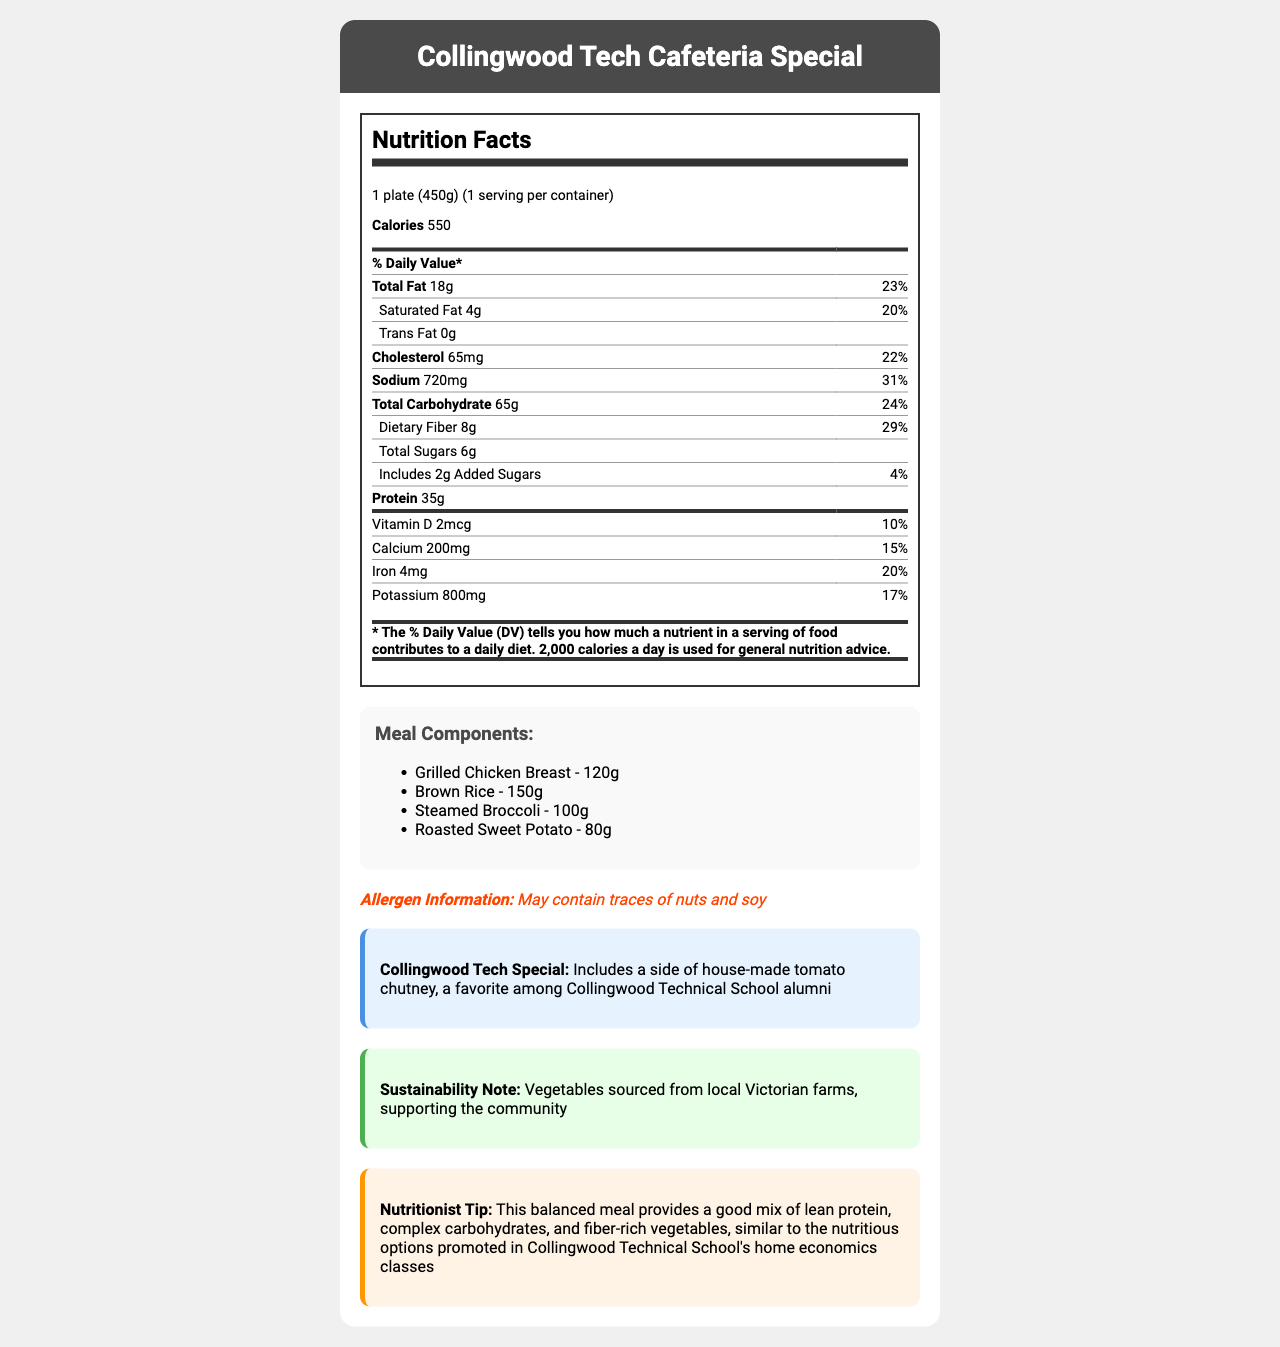what is the serving size of the balanced meal? The serving size is clearly stated in the "Nutrition Facts" section at the beginning of the document.
Answer: 1 plate (450g) how many calories are there per serving? The calorie content is listed right under the serving size in the Nutrition Facts section.
Answer: 550 calories what is the total fat content and its daily value percentage? The total fat amount and its daily value percentage are listed in the Nutrition Facts table.
Answer: 18g, 23% how much dietary fiber does this meal contain? The dietary fiber content is listed in the Nutrition Facts table under Total Carbohydrate.
Answer: 8g what are the meal components and their respective quantities? The meal components and their quantities are listed in the "Meal Components" section.
Answer: Grilled Chicken Breast - 120g, Brown Rice - 150g, Steamed Broccoli - 100g, Roasted Sweet Potato - 80g which of the following vitamins and minerals is present in the highest amount per serving? A. Vitamin D B. Calcium C. Iron D. Potassium Potassium is present in the highest amount at 800mg, which is higher than any other vitamins and minerals listed.
Answer: D. Potassium what is the percentage daily value of sodium in this meal? A. 22% B. 15% C. 31% D. 17% The percentage daily value of sodium is 31% as listed in the Nutrition Facts table.
Answer: C. 31% does the meal contain any trans fat? The document states "Trans Fat 0g," indicating there is no trans fat in the meal.
Answer: No is there any information about allergens in the meal? The document includes an allergen information section stating the meal may contain traces of nuts and soy.
Answer: Yes summarize the main idea of the document. The entire document is centered around providing complete nutritional information, meal components, allergen warnings, and additional notes about a specific healthy, balanced meal option at Collingwood Technical School cafeteria.
Answer: The document provides a detailed nutrition facts label for a balanced cafeteria-style meal served at Collingwood Technical School. It includes information on serving size, calorie content, fats, cholesterol, sodium, carbohydrates, fiber, sugars, protein, and various vitamins and minerals. The document also lists the meal components, mentions possible allergens, highlights a special note about a favorite alumni side, underlines sustainability efforts, and provides a nutritionist tip. what is the method of preparation for the meal listed in the document? The preparation method is noted at the end of the meal components section as "Cafeteria-style, freshly prepared."
Answer: Cafeteria-style, freshly prepared how is the Collingwood Tech Special described? The Collingwood Tech Special is described in a dedicated section within the document.
Answer: Includes a side of house-made tomato chutney, a favorite among Collingwood Technical School alumni what are the total sugars and added sugars in the meal? The total sugars and added sugars are listed in the Nutrition Facts table under Total Carbohydrate.
Answer: Total sugars: 6g, Added sugars: 2g what is the sustainability note mentioned in the document? The note is highlighted in the sustainability section towards the end of the document.
Answer: Vegetables sourced from local Victorian farms, supporting the community who provided the nutritionist tip and what is it about? The document contains a section for a nutritionist tip but does not provide any specific name for the nutritionist. The tip discusses the benefits of a balanced meal with lean protein, complex carbohydrates, and fiber-rich vegetables.
Answer: Cannot be determined 